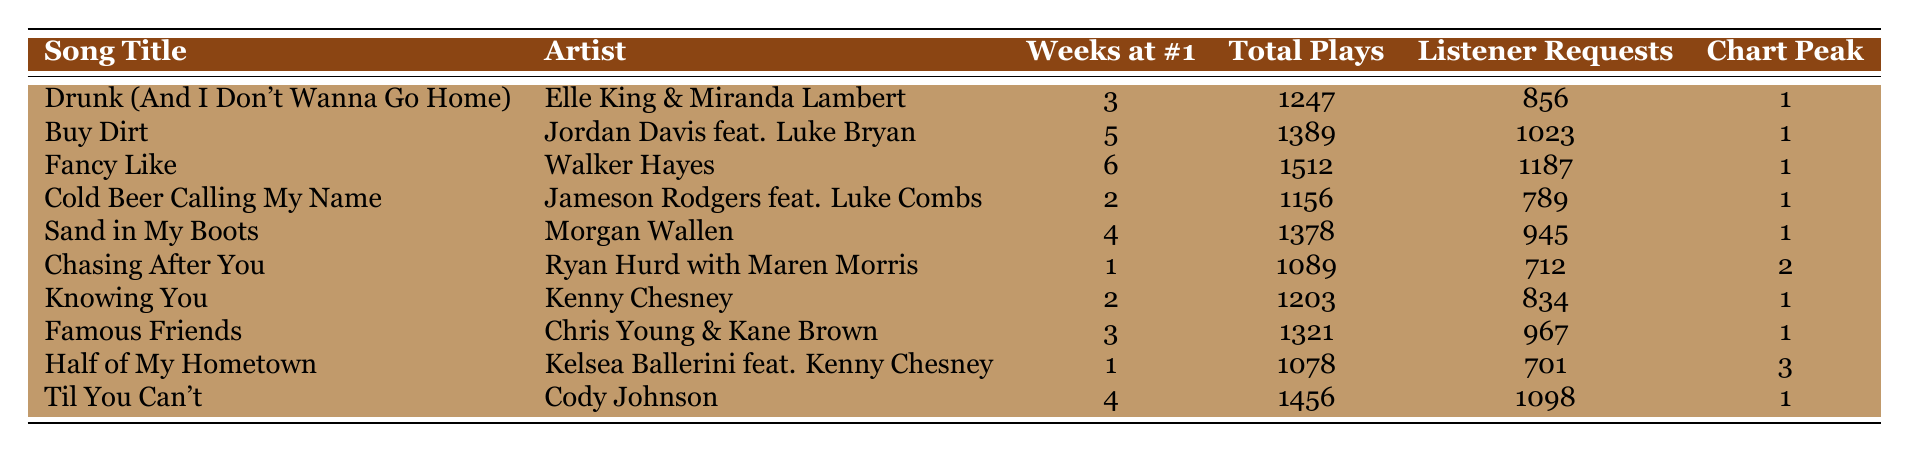What's the song with the most weeks at #1? "Fancy Like" by Walker Hayes has the most weeks at #1, totaling 6 weeks as indicated in the "Weeks at #1" column.
Answer: "Fancy Like" Which artist collaborated with Luke Bryan on a top-rated song? "Buy Dirt" is the song that features Jordan Davis collaborating with Luke Bryan, as shown in the "Artist" column next to the song title.
Answer: Jordan Davis feat. Luke Bryan How many total plays did "Til You Can't" receive? The song "Til You Can't" received a total of 1456 plays, which is noted in the "Total Plays" column.
Answer: 1456 Is "Chasing After You" among the top 3 songs in terms of total plays? No, "Chasing After You" with 1089 total plays is not in the top 3 as it ranks below the top three songs by total plays.
Answer: No What’s the average number of listener requests for all songs? Summing up listener requests gives 856 + 1023 + 1187 + 789 + 945 + 712 + 834 + 967 + 701 + 1098 = 8348. Dividing by the number of songs, which is 10, gives 8348/10 = 834.8, approximately 835.
Answer: Approximately 835 Which song received the least listener requests? "Half of My Hometown" received the least listener requests with a total of 701 requests, which is the lowest value in the "Listener Requests" column.
Answer: 701 How many songs reached the chart peak position of 3? Two songs, "Half of My Hometown" and "Chasing After You," achieved a chart peak position of 3 according to the "Chart Peak Position" column.
Answer: 2 What is the total number of weeks at #1 for all songs listed? Adding the weeks at #1 gives 3 + 5 + 6 + 2 + 4 + 1 + 2 + 3 + 1 + 4 = 31 weeks in total.
Answer: 31 Which song had a higher total plays: "Cold Beer Calling My Name" or "Knowing You"? "Knowing You" had 1203 total plays, while "Cold Beer Calling My Name" had 1156, making "Knowing You" the higher of the two.
Answer: "Knowing You" Is there a song that has both a peak position and two weeks at #1? Yes, "Knowing You" has a peak position of 1 and has spent 2 weeks at #1. This can be verified from the respective columns.
Answer: Yes 